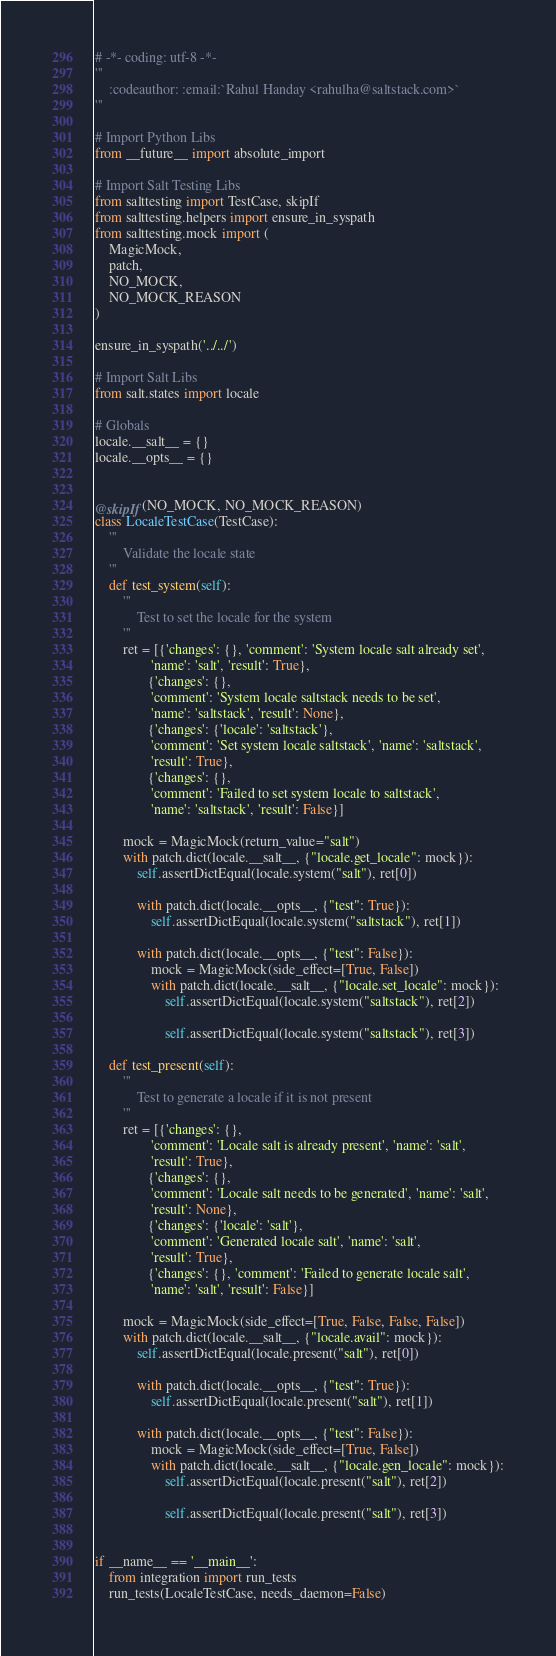<code> <loc_0><loc_0><loc_500><loc_500><_Python_># -*- coding: utf-8 -*-
'''
    :codeauthor: :email:`Rahul Handay <rahulha@saltstack.com>`
'''

# Import Python Libs
from __future__ import absolute_import

# Import Salt Testing Libs
from salttesting import TestCase, skipIf
from salttesting.helpers import ensure_in_syspath
from salttesting.mock import (
    MagicMock,
    patch,
    NO_MOCK,
    NO_MOCK_REASON
)

ensure_in_syspath('../../')

# Import Salt Libs
from salt.states import locale

# Globals
locale.__salt__ = {}
locale.__opts__ = {}


@skipIf(NO_MOCK, NO_MOCK_REASON)
class LocaleTestCase(TestCase):
    '''
        Validate the locale state
    '''
    def test_system(self):
        '''
            Test to set the locale for the system
        '''
        ret = [{'changes': {}, 'comment': 'System locale salt already set',
                'name': 'salt', 'result': True},
               {'changes': {},
                'comment': 'System locale saltstack needs to be set',
                'name': 'saltstack', 'result': None},
               {'changes': {'locale': 'saltstack'},
                'comment': 'Set system locale saltstack', 'name': 'saltstack',
                'result': True},
               {'changes': {},
                'comment': 'Failed to set system locale to saltstack',
                'name': 'saltstack', 'result': False}]

        mock = MagicMock(return_value="salt")
        with patch.dict(locale.__salt__, {"locale.get_locale": mock}):
            self.assertDictEqual(locale.system("salt"), ret[0])

            with patch.dict(locale.__opts__, {"test": True}):
                self.assertDictEqual(locale.system("saltstack"), ret[1])

            with patch.dict(locale.__opts__, {"test": False}):
                mock = MagicMock(side_effect=[True, False])
                with patch.dict(locale.__salt__, {"locale.set_locale": mock}):
                    self.assertDictEqual(locale.system("saltstack"), ret[2])

                    self.assertDictEqual(locale.system("saltstack"), ret[3])

    def test_present(self):
        '''
            Test to generate a locale if it is not present
        '''
        ret = [{'changes': {},
                'comment': 'Locale salt is already present', 'name': 'salt',
                'result': True},
               {'changes': {},
                'comment': 'Locale salt needs to be generated', 'name': 'salt',
                'result': None},
               {'changes': {'locale': 'salt'},
                'comment': 'Generated locale salt', 'name': 'salt',
                'result': True},
               {'changes': {}, 'comment': 'Failed to generate locale salt',
                'name': 'salt', 'result': False}]

        mock = MagicMock(side_effect=[True, False, False, False])
        with patch.dict(locale.__salt__, {"locale.avail": mock}):
            self.assertDictEqual(locale.present("salt"), ret[0])

            with patch.dict(locale.__opts__, {"test": True}):
                self.assertDictEqual(locale.present("salt"), ret[1])

            with patch.dict(locale.__opts__, {"test": False}):
                mock = MagicMock(side_effect=[True, False])
                with patch.dict(locale.__salt__, {"locale.gen_locale": mock}):
                    self.assertDictEqual(locale.present("salt"), ret[2])

                    self.assertDictEqual(locale.present("salt"), ret[3])


if __name__ == '__main__':
    from integration import run_tests
    run_tests(LocaleTestCase, needs_daemon=False)
</code> 